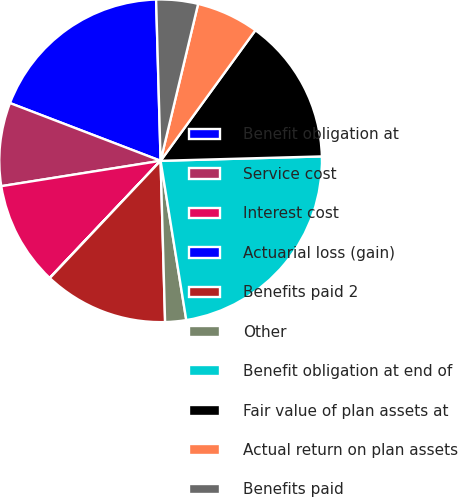Convert chart. <chart><loc_0><loc_0><loc_500><loc_500><pie_chart><fcel>Benefit obligation at<fcel>Service cost<fcel>Interest cost<fcel>Actuarial loss (gain)<fcel>Benefits paid 2<fcel>Other<fcel>Benefit obligation at end of<fcel>Fair value of plan assets at<fcel>Actual return on plan assets<fcel>Benefits paid<nl><fcel>18.73%<fcel>8.34%<fcel>10.42%<fcel>0.02%<fcel>12.49%<fcel>2.1%<fcel>22.89%<fcel>14.57%<fcel>6.26%<fcel>4.18%<nl></chart> 